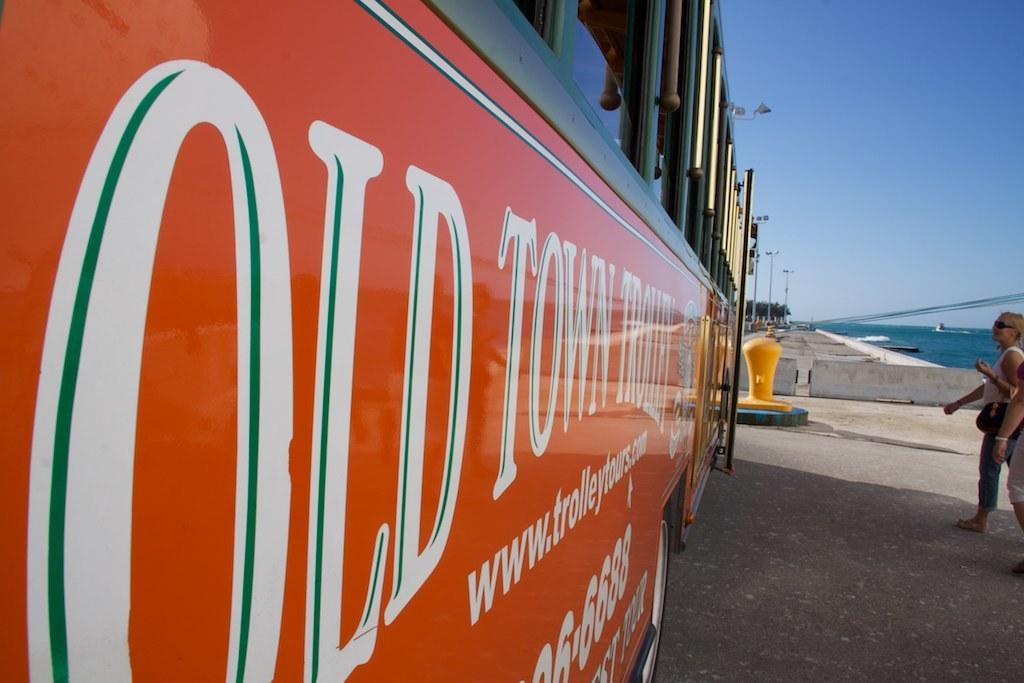<image>
Give a short and clear explanation of the subsequent image. Orange bus with white words that says Old Town. 